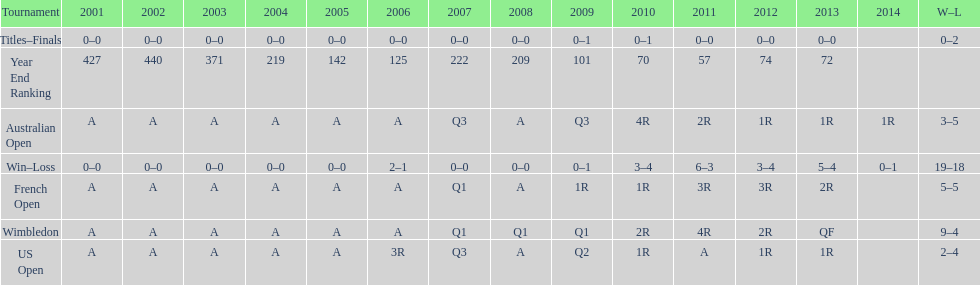What was the total number of matches played from 2001 to 2014? 37. 